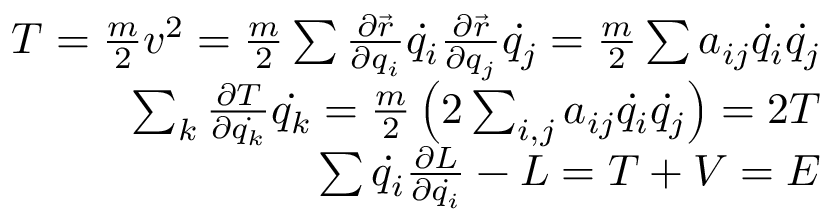<formula> <loc_0><loc_0><loc_500><loc_500>{ \begin{array} { r } { T = { \frac { m } { 2 } } v ^ { 2 } = { \frac { m } { 2 } } \sum { \frac { \partial { \vec { r } } } { \partial q _ { i } } } { \dot { q _ { i } } } { \frac { \partial { \vec { r } } } { \partial q _ { j } } } { \dot { q _ { j } } } = { \frac { m } { 2 } } \sum a _ { i j } { \dot { q _ { i } } } { \dot { q _ { j } } } } \\ { \sum _ { k } { \frac { \partial T } { \partial { \dot { q _ { k } } } } } { \dot { q _ { k } } } = { \frac { m } { 2 } } \left ( 2 \sum _ { i , j } a _ { i j } { \dot { q _ { i } } } { \dot { q _ { j } } } \right ) = 2 T } \\ { \sum { \dot { q _ { i } } } { \frac { \partial L } { \partial { \dot { q _ { i } } } } } - L = T + V = E } \end{array} }</formula> 